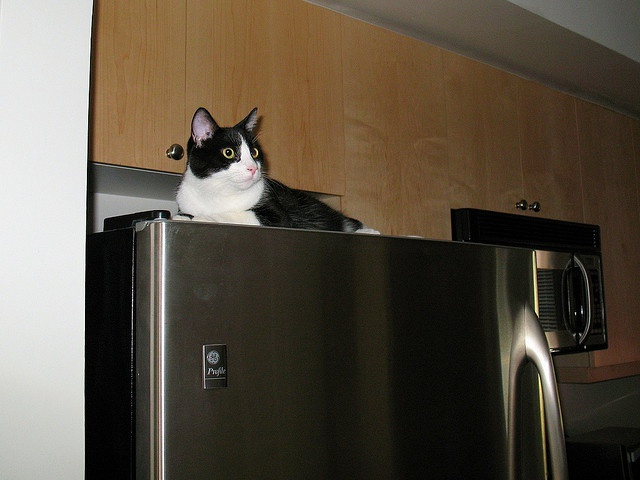Describe the objects in this image and their specific colors. I can see refrigerator in lightgray, black, and gray tones, cat in lightgray, black, gray, and darkgray tones, and microwave in lightgray, black, and gray tones in this image. 